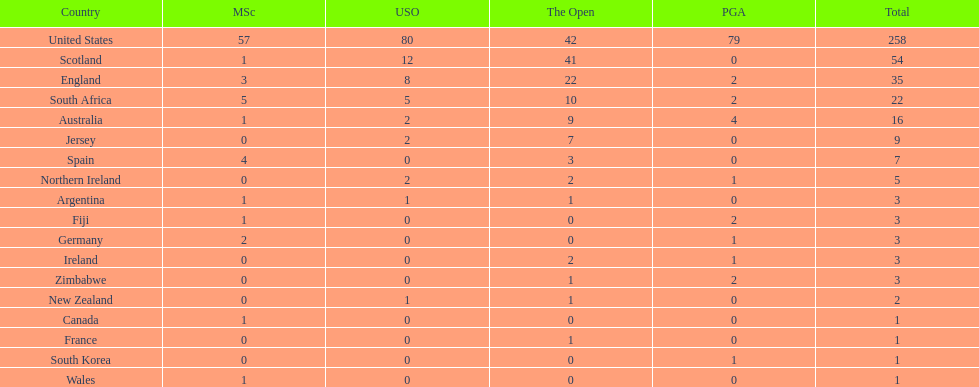Is the united stated or scotland better? United States. 